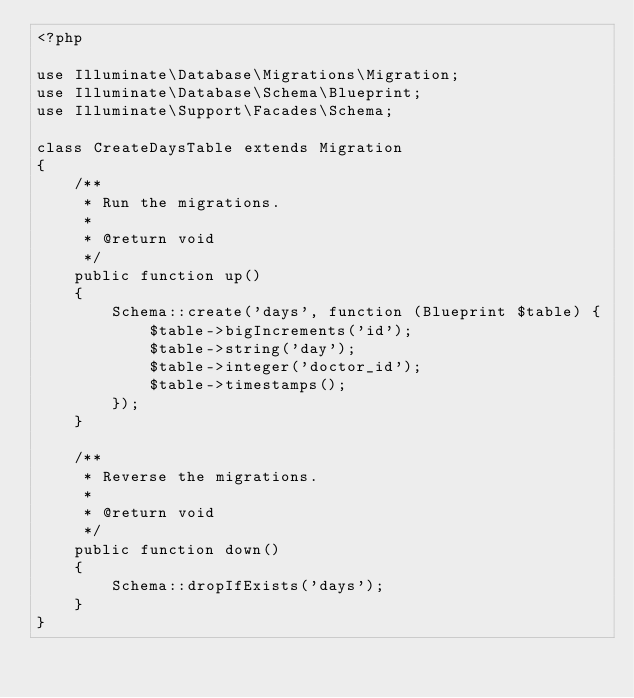Convert code to text. <code><loc_0><loc_0><loc_500><loc_500><_PHP_><?php

use Illuminate\Database\Migrations\Migration;
use Illuminate\Database\Schema\Blueprint;
use Illuminate\Support\Facades\Schema;

class CreateDaysTable extends Migration
{
    /**
     * Run the migrations.
     *
     * @return void
     */
    public function up()
    {
        Schema::create('days', function (Blueprint $table) {
            $table->bigIncrements('id');
            $table->string('day');
            $table->integer('doctor_id');
            $table->timestamps();
        });
    }

    /**
     * Reverse the migrations.
     *
     * @return void
     */
    public function down()
    {
        Schema::dropIfExists('days');
    }
}
</code> 